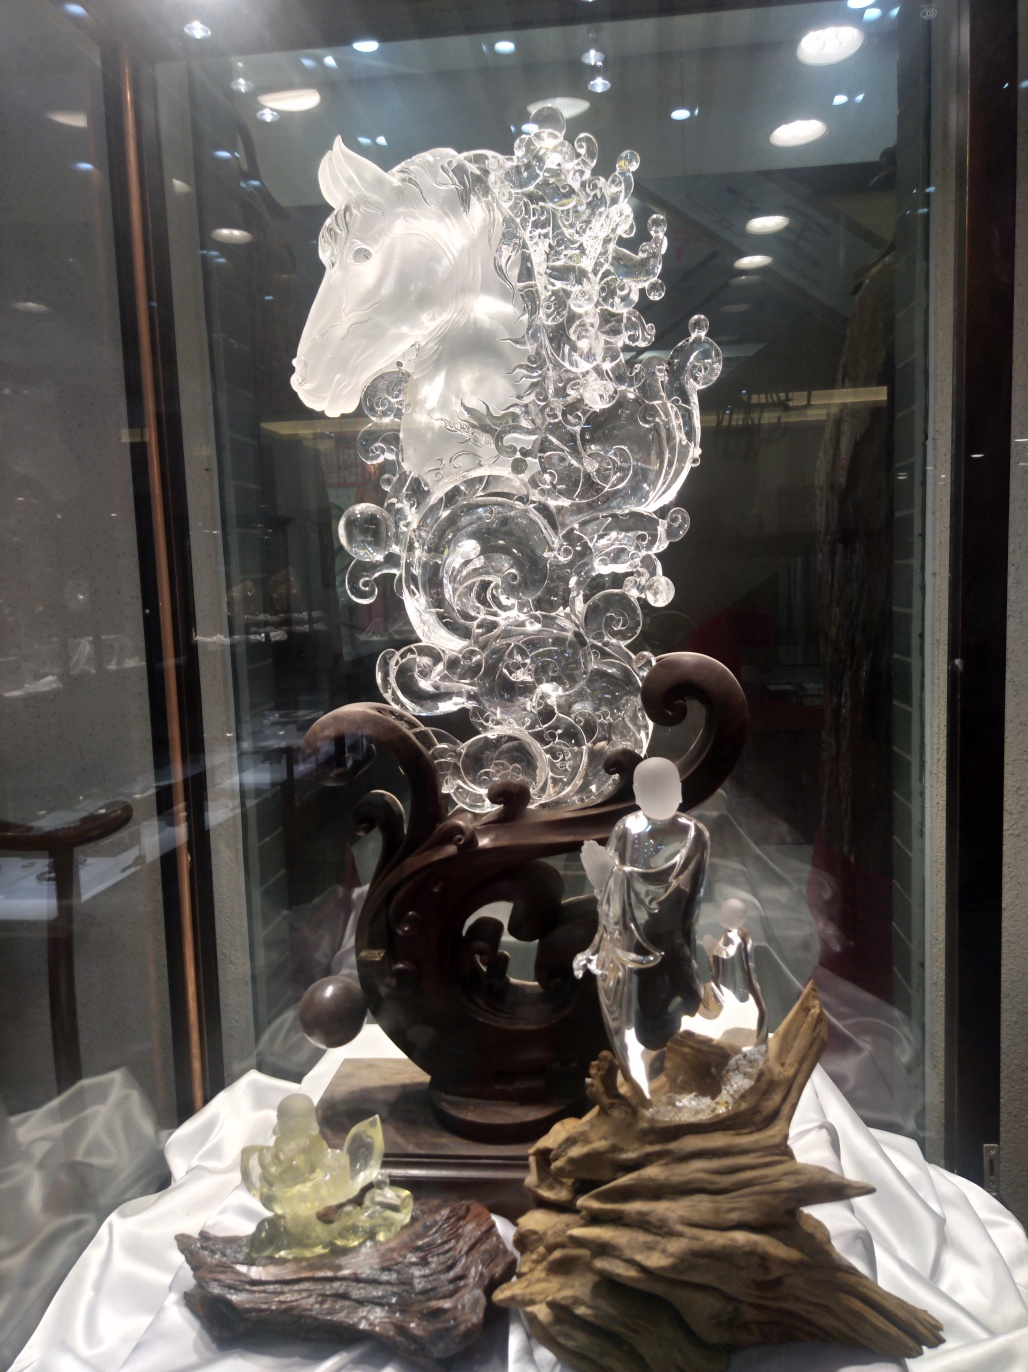What can be said about the quality of this image?
A. Mediocre
B. Terrible
C. Good
Answer with the option's letter from the given choices directly. C. The image quality is good as it displays the subject in focus with sufficient lighting, though reflections and background distractions slightly hamper the clarity. 